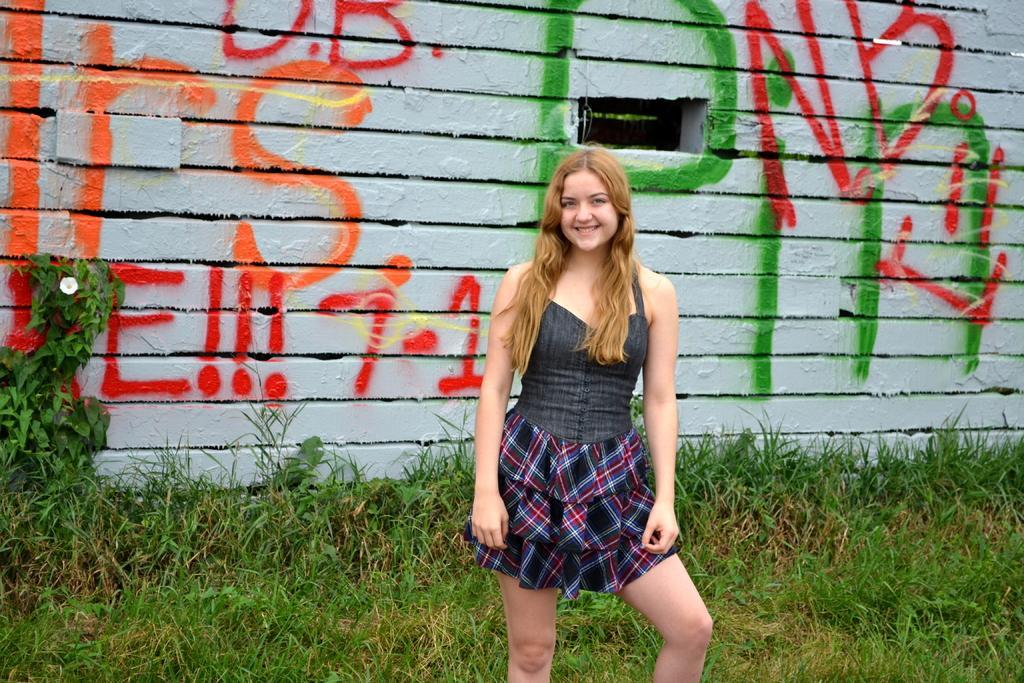Could you give a brief overview of what you see in this image? In the center of the image we can see a lady standing and smiling. In the background there is a wall and we can see graffiti on it. At the bottom there is grass. 